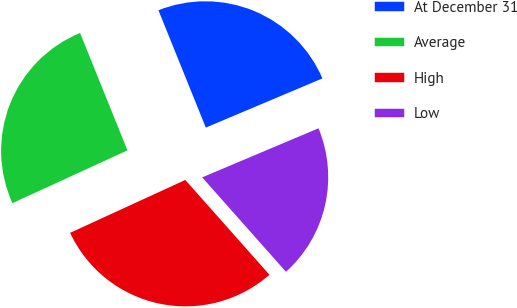Convert chart. <chart><loc_0><loc_0><loc_500><loc_500><pie_chart><fcel>At December 31<fcel>Average<fcel>High<fcel>Low<nl><fcel>24.75%<fcel>25.74%<fcel>29.7%<fcel>19.8%<nl></chart> 